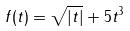<formula> <loc_0><loc_0><loc_500><loc_500>f ( t ) = \sqrt { | t | } + 5 t ^ { 3 }</formula> 